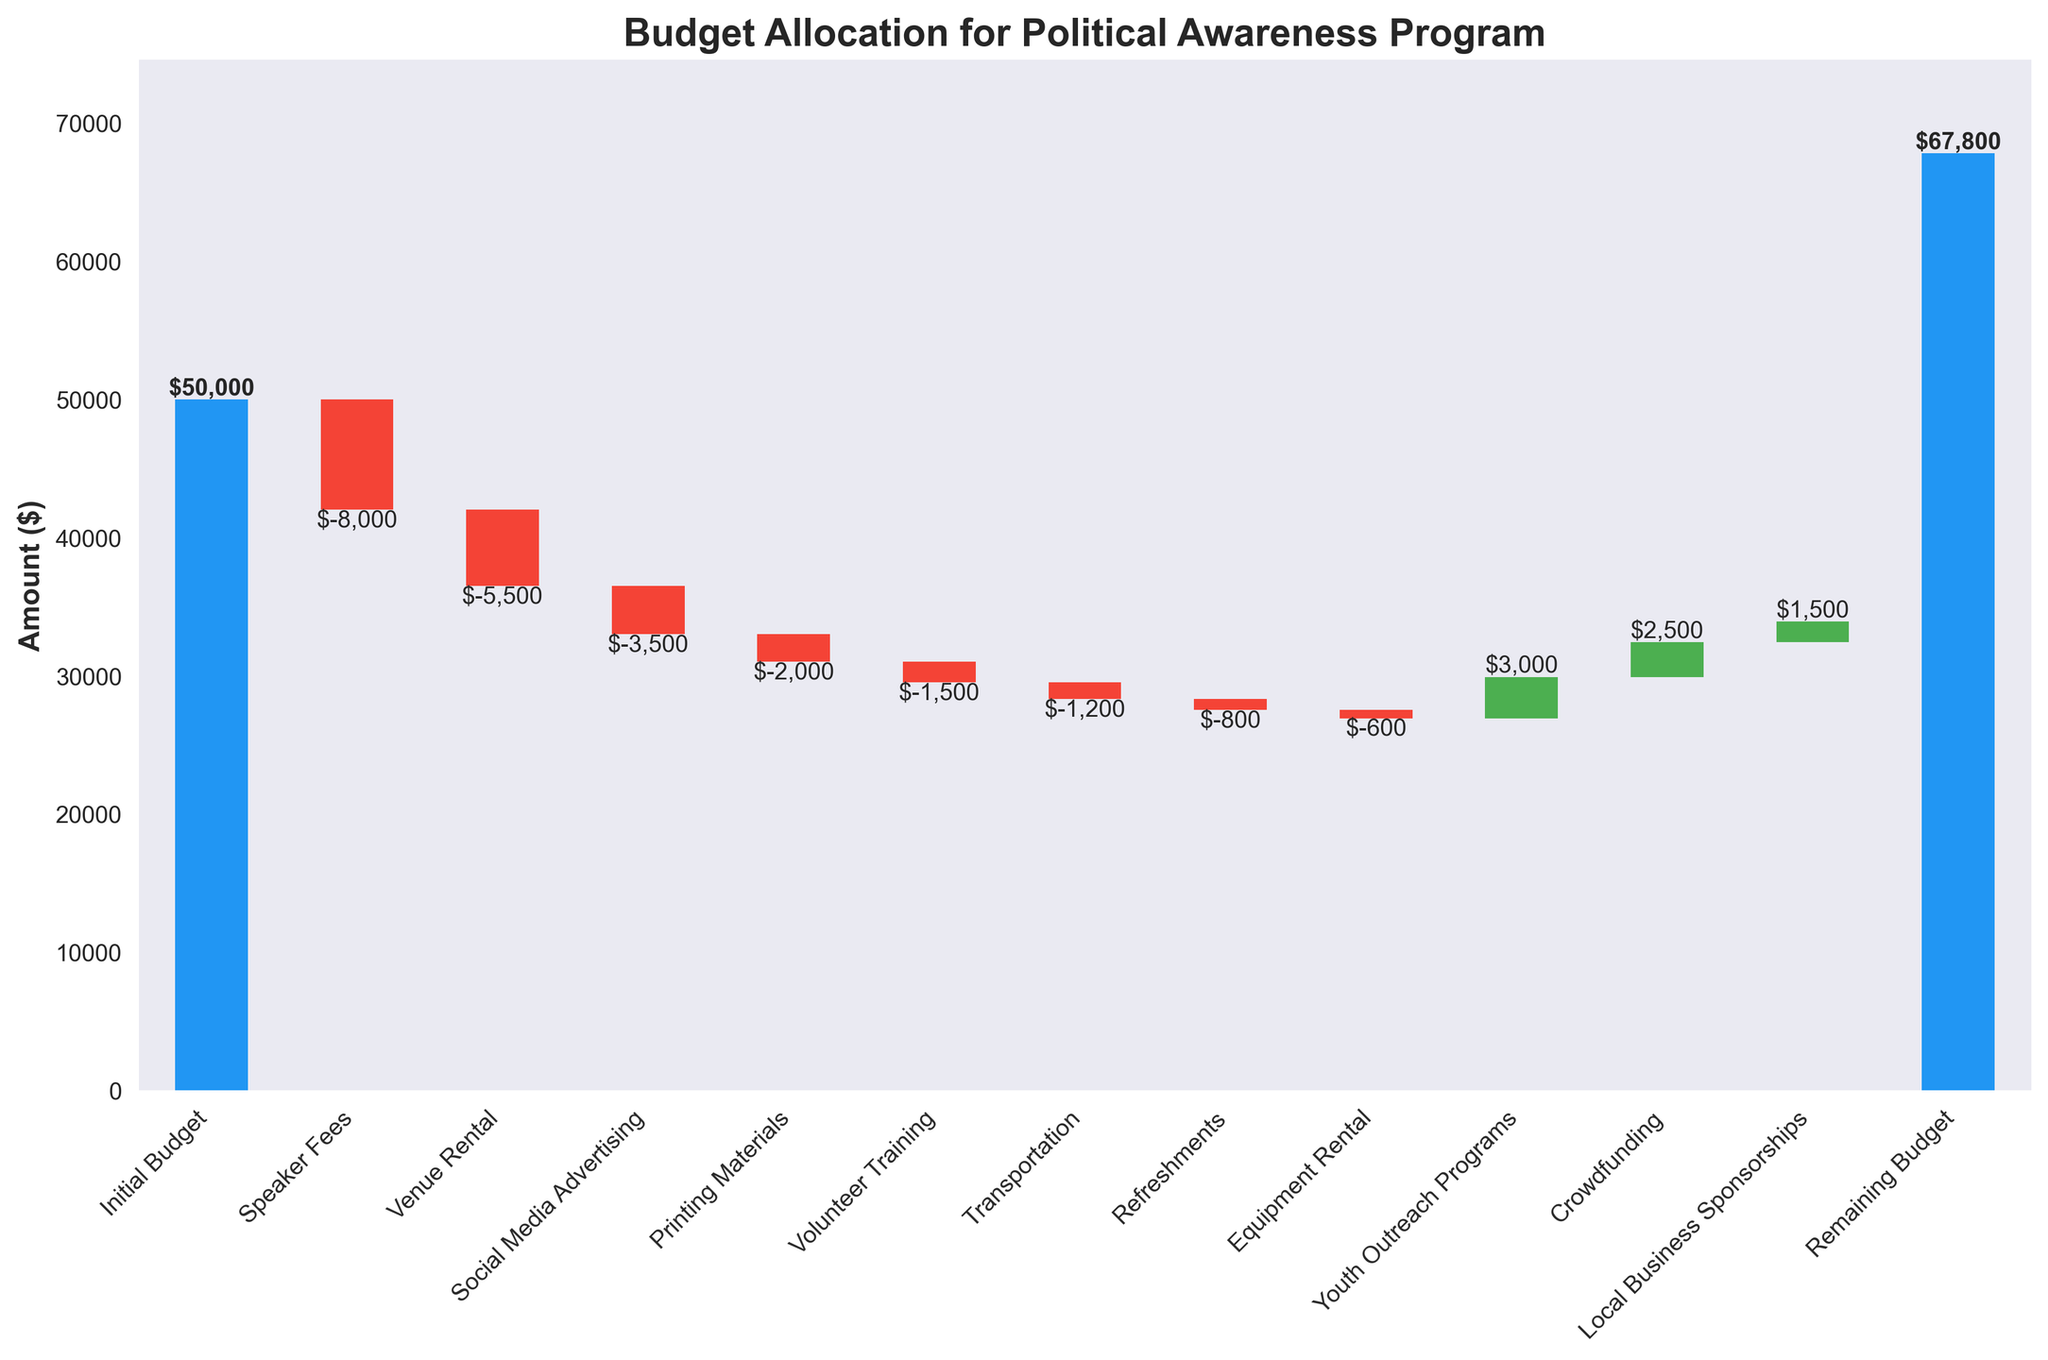What is the title of the chart? The title is displayed at the top of the figure. It provides a clear summary of what the chart is depicting.
Answer: Budget Allocation for Political Awareness Program How many categories are shown in the chart? By counting all the labeled categories on the x-axis, from ‘Initial Budget’ to ‘Remaining Budget’, we can determine the number of categories.
Answer: 13 What's the value of the highest individual expense? By looking at the negative values in the chart, the highest individual expense corresponds to the longest bar below the x-axis.
Answer: $8000 What’s the total amount added from positive contributions? To find this, sum up all the positive contributions: $3000 (Youth Outreach Programs), $2500 (Crowdfunding), and $1500 (Local Business Sponsorships). So, $3000 + $2500 + $1500 = $7000.
Answer: $7000 How does the 'Speaker Fees' expense compare to the 'Venue Rental' expense? Locate both expenses in the chart. ‘Speaker Fees’ is higher compared to ‘Venue Rental’ as the bar for ‘Speaker Fees’ is longer. Specifically, ‘Speaker Fees’ is $8000, while ‘Venue Rental’ is $5500.
Answer: Speaker Fees > Venue Rental What is the difference between the initial budget and the remaining budget? Subtract the remaining budget from the initial budget: $50000 (Initial Budget) - $33900 (Remaining Budget).
Answer: $16100 Which category has the smallest expense? By assessing the length of the bars (negative values), the category with the smallest expense will be the one with the shortest negative bar.
Answer: Equipment Rental What is the cumulative amount after the 'Printing Materials' expense? By adding amounts sequentially up to and including 'Printing Materials': $50000 (Initial) - $8000 (Speaker Fees) - $5500 (Venue Rental) - $3500 (Social Media Advertising) - $2000 (Printing Materials).
Answer: $31000 What’s the combined cost of 'Volunteer Training' and 'Transportation'? Add the amounts for these two expenses: $1500 (Volunteer Training) + $1200 (Transportation).
Answer: $2700 How does the remaining budget compare to the initial budget? The remaining budget is less than the initial budget, which can be confirmed by comparing the two values directly from the chart.
Answer: Less 